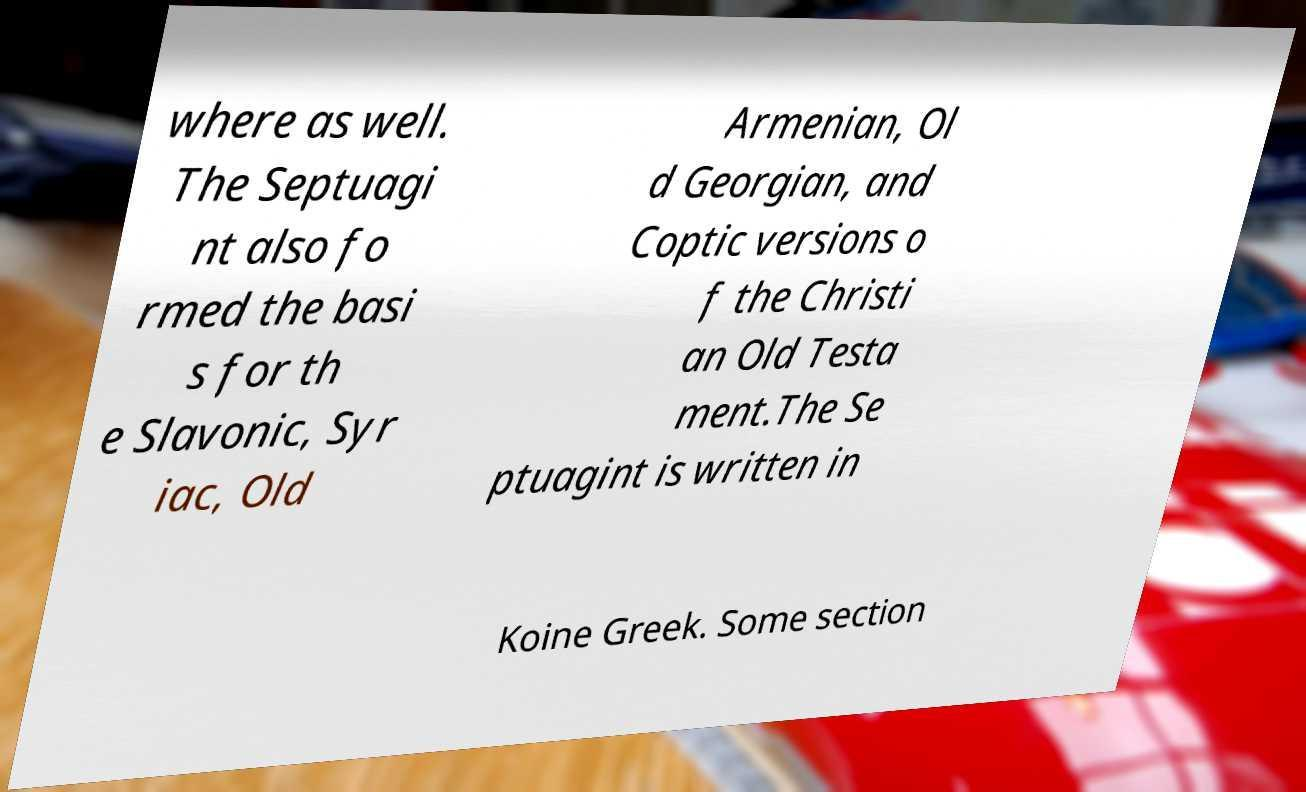Please identify and transcribe the text found in this image. where as well. The Septuagi nt also fo rmed the basi s for th e Slavonic, Syr iac, Old Armenian, Ol d Georgian, and Coptic versions o f the Christi an Old Testa ment.The Se ptuagint is written in Koine Greek. Some section 